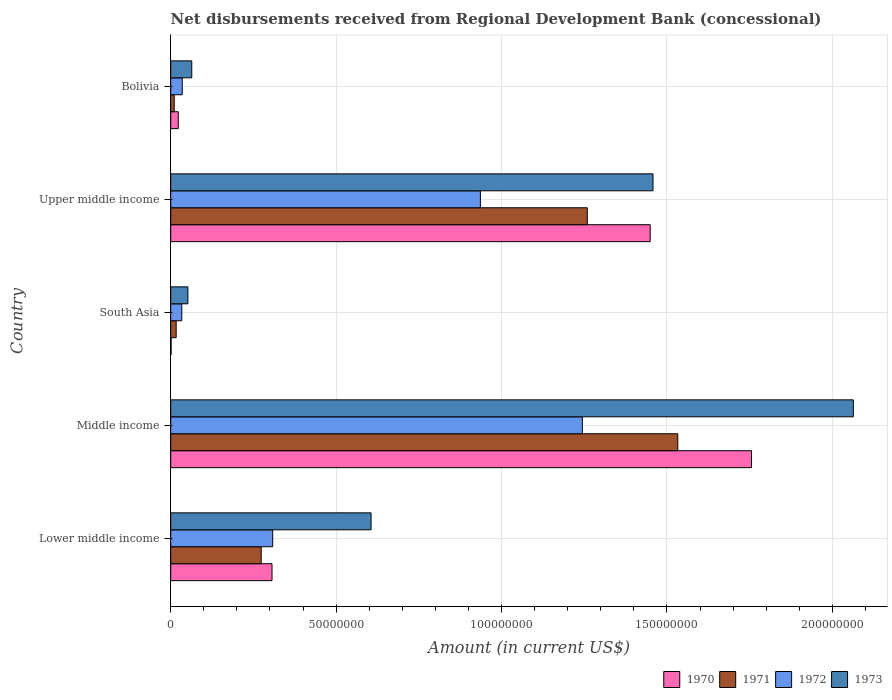How many different coloured bars are there?
Make the answer very short. 4. How many bars are there on the 2nd tick from the top?
Your answer should be very brief. 4. What is the label of the 4th group of bars from the top?
Keep it short and to the point. Middle income. In how many cases, is the number of bars for a given country not equal to the number of legend labels?
Provide a short and direct response. 0. What is the amount of disbursements received from Regional Development Bank in 1973 in Middle income?
Your answer should be very brief. 2.06e+08. Across all countries, what is the maximum amount of disbursements received from Regional Development Bank in 1970?
Your response must be concise. 1.76e+08. Across all countries, what is the minimum amount of disbursements received from Regional Development Bank in 1970?
Provide a short and direct response. 1.09e+05. In which country was the amount of disbursements received from Regional Development Bank in 1971 minimum?
Offer a terse response. Bolivia. What is the total amount of disbursements received from Regional Development Bank in 1971 in the graph?
Offer a very short reply. 3.09e+08. What is the difference between the amount of disbursements received from Regional Development Bank in 1971 in Bolivia and that in Middle income?
Give a very brief answer. -1.52e+08. What is the difference between the amount of disbursements received from Regional Development Bank in 1970 in Bolivia and the amount of disbursements received from Regional Development Bank in 1971 in Middle income?
Provide a short and direct response. -1.51e+08. What is the average amount of disbursements received from Regional Development Bank in 1970 per country?
Offer a very short reply. 7.07e+07. What is the difference between the amount of disbursements received from Regional Development Bank in 1970 and amount of disbursements received from Regional Development Bank in 1973 in Bolivia?
Make the answer very short. -4.09e+06. What is the ratio of the amount of disbursements received from Regional Development Bank in 1973 in Bolivia to that in Middle income?
Give a very brief answer. 0.03. Is the difference between the amount of disbursements received from Regional Development Bank in 1970 in Middle income and Upper middle income greater than the difference between the amount of disbursements received from Regional Development Bank in 1973 in Middle income and Upper middle income?
Offer a very short reply. No. What is the difference between the highest and the second highest amount of disbursements received from Regional Development Bank in 1972?
Your response must be concise. 3.08e+07. What is the difference between the highest and the lowest amount of disbursements received from Regional Development Bank in 1972?
Provide a short and direct response. 1.21e+08. Is the sum of the amount of disbursements received from Regional Development Bank in 1971 in Bolivia and Upper middle income greater than the maximum amount of disbursements received from Regional Development Bank in 1973 across all countries?
Keep it short and to the point. No. Is it the case that in every country, the sum of the amount of disbursements received from Regional Development Bank in 1973 and amount of disbursements received from Regional Development Bank in 1972 is greater than the sum of amount of disbursements received from Regional Development Bank in 1971 and amount of disbursements received from Regional Development Bank in 1970?
Ensure brevity in your answer.  No. What does the 2nd bar from the bottom in Upper middle income represents?
Your response must be concise. 1971. How many bars are there?
Keep it short and to the point. 20. Are all the bars in the graph horizontal?
Offer a terse response. Yes. Are the values on the major ticks of X-axis written in scientific E-notation?
Your response must be concise. No. Does the graph contain any zero values?
Make the answer very short. No. Where does the legend appear in the graph?
Provide a short and direct response. Bottom right. How are the legend labels stacked?
Your answer should be very brief. Horizontal. What is the title of the graph?
Make the answer very short. Net disbursements received from Regional Development Bank (concessional). What is the label or title of the X-axis?
Provide a short and direct response. Amount (in current US$). What is the label or title of the Y-axis?
Your answer should be compact. Country. What is the Amount (in current US$) in 1970 in Lower middle income?
Your response must be concise. 3.06e+07. What is the Amount (in current US$) in 1971 in Lower middle income?
Provide a succinct answer. 2.74e+07. What is the Amount (in current US$) in 1972 in Lower middle income?
Offer a terse response. 3.08e+07. What is the Amount (in current US$) of 1973 in Lower middle income?
Provide a succinct answer. 6.06e+07. What is the Amount (in current US$) in 1970 in Middle income?
Your response must be concise. 1.76e+08. What is the Amount (in current US$) in 1971 in Middle income?
Keep it short and to the point. 1.53e+08. What is the Amount (in current US$) of 1972 in Middle income?
Ensure brevity in your answer.  1.24e+08. What is the Amount (in current US$) in 1973 in Middle income?
Offer a very short reply. 2.06e+08. What is the Amount (in current US$) of 1970 in South Asia?
Your answer should be very brief. 1.09e+05. What is the Amount (in current US$) in 1971 in South Asia?
Your answer should be very brief. 1.65e+06. What is the Amount (in current US$) of 1972 in South Asia?
Keep it short and to the point. 3.35e+06. What is the Amount (in current US$) of 1973 in South Asia?
Your answer should be very brief. 5.18e+06. What is the Amount (in current US$) in 1970 in Upper middle income?
Provide a succinct answer. 1.45e+08. What is the Amount (in current US$) in 1971 in Upper middle income?
Provide a succinct answer. 1.26e+08. What is the Amount (in current US$) in 1972 in Upper middle income?
Provide a succinct answer. 9.36e+07. What is the Amount (in current US$) of 1973 in Upper middle income?
Give a very brief answer. 1.46e+08. What is the Amount (in current US$) of 1970 in Bolivia?
Your response must be concise. 2.27e+06. What is the Amount (in current US$) of 1971 in Bolivia?
Offer a very short reply. 1.06e+06. What is the Amount (in current US$) of 1972 in Bolivia?
Your answer should be compact. 3.48e+06. What is the Amount (in current US$) of 1973 in Bolivia?
Your answer should be very brief. 6.36e+06. Across all countries, what is the maximum Amount (in current US$) of 1970?
Offer a terse response. 1.76e+08. Across all countries, what is the maximum Amount (in current US$) in 1971?
Ensure brevity in your answer.  1.53e+08. Across all countries, what is the maximum Amount (in current US$) in 1972?
Make the answer very short. 1.24e+08. Across all countries, what is the maximum Amount (in current US$) of 1973?
Provide a short and direct response. 2.06e+08. Across all countries, what is the minimum Amount (in current US$) in 1970?
Your response must be concise. 1.09e+05. Across all countries, what is the minimum Amount (in current US$) of 1971?
Make the answer very short. 1.06e+06. Across all countries, what is the minimum Amount (in current US$) of 1972?
Your answer should be compact. 3.35e+06. Across all countries, what is the minimum Amount (in current US$) of 1973?
Your answer should be compact. 5.18e+06. What is the total Amount (in current US$) in 1970 in the graph?
Keep it short and to the point. 3.53e+08. What is the total Amount (in current US$) in 1971 in the graph?
Your answer should be compact. 3.09e+08. What is the total Amount (in current US$) in 1972 in the graph?
Keep it short and to the point. 2.56e+08. What is the total Amount (in current US$) of 1973 in the graph?
Give a very brief answer. 4.24e+08. What is the difference between the Amount (in current US$) of 1970 in Lower middle income and that in Middle income?
Your answer should be compact. -1.45e+08. What is the difference between the Amount (in current US$) in 1971 in Lower middle income and that in Middle income?
Provide a short and direct response. -1.26e+08. What is the difference between the Amount (in current US$) of 1972 in Lower middle income and that in Middle income?
Your answer should be compact. -9.36e+07. What is the difference between the Amount (in current US$) in 1973 in Lower middle income and that in Middle income?
Give a very brief answer. -1.46e+08. What is the difference between the Amount (in current US$) in 1970 in Lower middle income and that in South Asia?
Provide a short and direct response. 3.05e+07. What is the difference between the Amount (in current US$) of 1971 in Lower middle income and that in South Asia?
Make the answer very short. 2.57e+07. What is the difference between the Amount (in current US$) of 1972 in Lower middle income and that in South Asia?
Give a very brief answer. 2.75e+07. What is the difference between the Amount (in current US$) in 1973 in Lower middle income and that in South Asia?
Keep it short and to the point. 5.54e+07. What is the difference between the Amount (in current US$) in 1970 in Lower middle income and that in Upper middle income?
Your response must be concise. -1.14e+08. What is the difference between the Amount (in current US$) in 1971 in Lower middle income and that in Upper middle income?
Provide a short and direct response. -9.86e+07. What is the difference between the Amount (in current US$) of 1972 in Lower middle income and that in Upper middle income?
Make the answer very short. -6.28e+07. What is the difference between the Amount (in current US$) of 1973 in Lower middle income and that in Upper middle income?
Provide a short and direct response. -8.52e+07. What is the difference between the Amount (in current US$) in 1970 in Lower middle income and that in Bolivia?
Give a very brief answer. 2.84e+07. What is the difference between the Amount (in current US$) of 1971 in Lower middle income and that in Bolivia?
Ensure brevity in your answer.  2.63e+07. What is the difference between the Amount (in current US$) in 1972 in Lower middle income and that in Bolivia?
Provide a succinct answer. 2.73e+07. What is the difference between the Amount (in current US$) in 1973 in Lower middle income and that in Bolivia?
Your answer should be compact. 5.42e+07. What is the difference between the Amount (in current US$) of 1970 in Middle income and that in South Asia?
Provide a short and direct response. 1.75e+08. What is the difference between the Amount (in current US$) of 1971 in Middle income and that in South Asia?
Give a very brief answer. 1.52e+08. What is the difference between the Amount (in current US$) of 1972 in Middle income and that in South Asia?
Offer a terse response. 1.21e+08. What is the difference between the Amount (in current US$) in 1973 in Middle income and that in South Asia?
Keep it short and to the point. 2.01e+08. What is the difference between the Amount (in current US$) in 1970 in Middle income and that in Upper middle income?
Give a very brief answer. 3.06e+07. What is the difference between the Amount (in current US$) in 1971 in Middle income and that in Upper middle income?
Give a very brief answer. 2.74e+07. What is the difference between the Amount (in current US$) in 1972 in Middle income and that in Upper middle income?
Offer a terse response. 3.08e+07. What is the difference between the Amount (in current US$) of 1973 in Middle income and that in Upper middle income?
Your answer should be compact. 6.06e+07. What is the difference between the Amount (in current US$) of 1970 in Middle income and that in Bolivia?
Your answer should be compact. 1.73e+08. What is the difference between the Amount (in current US$) in 1971 in Middle income and that in Bolivia?
Offer a terse response. 1.52e+08. What is the difference between the Amount (in current US$) in 1972 in Middle income and that in Bolivia?
Provide a succinct answer. 1.21e+08. What is the difference between the Amount (in current US$) in 1973 in Middle income and that in Bolivia?
Offer a terse response. 2.00e+08. What is the difference between the Amount (in current US$) of 1970 in South Asia and that in Upper middle income?
Offer a terse response. -1.45e+08. What is the difference between the Amount (in current US$) in 1971 in South Asia and that in Upper middle income?
Offer a terse response. -1.24e+08. What is the difference between the Amount (in current US$) of 1972 in South Asia and that in Upper middle income?
Your answer should be compact. -9.03e+07. What is the difference between the Amount (in current US$) of 1973 in South Asia and that in Upper middle income?
Offer a terse response. -1.41e+08. What is the difference between the Amount (in current US$) of 1970 in South Asia and that in Bolivia?
Your answer should be compact. -2.16e+06. What is the difference between the Amount (in current US$) in 1971 in South Asia and that in Bolivia?
Give a very brief answer. 5.92e+05. What is the difference between the Amount (in current US$) of 1972 in South Asia and that in Bolivia?
Give a very brief answer. -1.30e+05. What is the difference between the Amount (in current US$) of 1973 in South Asia and that in Bolivia?
Your answer should be very brief. -1.18e+06. What is the difference between the Amount (in current US$) in 1970 in Upper middle income and that in Bolivia?
Provide a short and direct response. 1.43e+08. What is the difference between the Amount (in current US$) in 1971 in Upper middle income and that in Bolivia?
Make the answer very short. 1.25e+08. What is the difference between the Amount (in current US$) in 1972 in Upper middle income and that in Bolivia?
Offer a very short reply. 9.01e+07. What is the difference between the Amount (in current US$) of 1973 in Upper middle income and that in Bolivia?
Give a very brief answer. 1.39e+08. What is the difference between the Amount (in current US$) in 1970 in Lower middle income and the Amount (in current US$) in 1971 in Middle income?
Provide a short and direct response. -1.23e+08. What is the difference between the Amount (in current US$) of 1970 in Lower middle income and the Amount (in current US$) of 1972 in Middle income?
Keep it short and to the point. -9.38e+07. What is the difference between the Amount (in current US$) in 1970 in Lower middle income and the Amount (in current US$) in 1973 in Middle income?
Offer a very short reply. -1.76e+08. What is the difference between the Amount (in current US$) of 1971 in Lower middle income and the Amount (in current US$) of 1972 in Middle income?
Ensure brevity in your answer.  -9.71e+07. What is the difference between the Amount (in current US$) of 1971 in Lower middle income and the Amount (in current US$) of 1973 in Middle income?
Offer a terse response. -1.79e+08. What is the difference between the Amount (in current US$) of 1972 in Lower middle income and the Amount (in current US$) of 1973 in Middle income?
Offer a terse response. -1.76e+08. What is the difference between the Amount (in current US$) in 1970 in Lower middle income and the Amount (in current US$) in 1971 in South Asia?
Provide a succinct answer. 2.90e+07. What is the difference between the Amount (in current US$) of 1970 in Lower middle income and the Amount (in current US$) of 1972 in South Asia?
Make the answer very short. 2.73e+07. What is the difference between the Amount (in current US$) of 1970 in Lower middle income and the Amount (in current US$) of 1973 in South Asia?
Your response must be concise. 2.54e+07. What is the difference between the Amount (in current US$) of 1971 in Lower middle income and the Amount (in current US$) of 1972 in South Asia?
Ensure brevity in your answer.  2.40e+07. What is the difference between the Amount (in current US$) in 1971 in Lower middle income and the Amount (in current US$) in 1973 in South Asia?
Keep it short and to the point. 2.22e+07. What is the difference between the Amount (in current US$) in 1972 in Lower middle income and the Amount (in current US$) in 1973 in South Asia?
Keep it short and to the point. 2.56e+07. What is the difference between the Amount (in current US$) in 1970 in Lower middle income and the Amount (in current US$) in 1971 in Upper middle income?
Keep it short and to the point. -9.53e+07. What is the difference between the Amount (in current US$) of 1970 in Lower middle income and the Amount (in current US$) of 1972 in Upper middle income?
Ensure brevity in your answer.  -6.30e+07. What is the difference between the Amount (in current US$) of 1970 in Lower middle income and the Amount (in current US$) of 1973 in Upper middle income?
Provide a short and direct response. -1.15e+08. What is the difference between the Amount (in current US$) of 1971 in Lower middle income and the Amount (in current US$) of 1972 in Upper middle income?
Offer a terse response. -6.63e+07. What is the difference between the Amount (in current US$) in 1971 in Lower middle income and the Amount (in current US$) in 1973 in Upper middle income?
Make the answer very short. -1.18e+08. What is the difference between the Amount (in current US$) in 1972 in Lower middle income and the Amount (in current US$) in 1973 in Upper middle income?
Provide a short and direct response. -1.15e+08. What is the difference between the Amount (in current US$) in 1970 in Lower middle income and the Amount (in current US$) in 1971 in Bolivia?
Offer a very short reply. 2.96e+07. What is the difference between the Amount (in current US$) of 1970 in Lower middle income and the Amount (in current US$) of 1972 in Bolivia?
Provide a short and direct response. 2.71e+07. What is the difference between the Amount (in current US$) of 1970 in Lower middle income and the Amount (in current US$) of 1973 in Bolivia?
Make the answer very short. 2.43e+07. What is the difference between the Amount (in current US$) of 1971 in Lower middle income and the Amount (in current US$) of 1972 in Bolivia?
Ensure brevity in your answer.  2.39e+07. What is the difference between the Amount (in current US$) in 1971 in Lower middle income and the Amount (in current US$) in 1973 in Bolivia?
Your answer should be compact. 2.10e+07. What is the difference between the Amount (in current US$) in 1972 in Lower middle income and the Amount (in current US$) in 1973 in Bolivia?
Offer a very short reply. 2.45e+07. What is the difference between the Amount (in current US$) in 1970 in Middle income and the Amount (in current US$) in 1971 in South Asia?
Provide a short and direct response. 1.74e+08. What is the difference between the Amount (in current US$) in 1970 in Middle income and the Amount (in current US$) in 1972 in South Asia?
Provide a short and direct response. 1.72e+08. What is the difference between the Amount (in current US$) in 1970 in Middle income and the Amount (in current US$) in 1973 in South Asia?
Keep it short and to the point. 1.70e+08. What is the difference between the Amount (in current US$) of 1971 in Middle income and the Amount (in current US$) of 1972 in South Asia?
Offer a very short reply. 1.50e+08. What is the difference between the Amount (in current US$) of 1971 in Middle income and the Amount (in current US$) of 1973 in South Asia?
Keep it short and to the point. 1.48e+08. What is the difference between the Amount (in current US$) of 1972 in Middle income and the Amount (in current US$) of 1973 in South Asia?
Provide a succinct answer. 1.19e+08. What is the difference between the Amount (in current US$) in 1970 in Middle income and the Amount (in current US$) in 1971 in Upper middle income?
Keep it short and to the point. 4.96e+07. What is the difference between the Amount (in current US$) in 1970 in Middle income and the Amount (in current US$) in 1972 in Upper middle income?
Your response must be concise. 8.19e+07. What is the difference between the Amount (in current US$) in 1970 in Middle income and the Amount (in current US$) in 1973 in Upper middle income?
Offer a terse response. 2.98e+07. What is the difference between the Amount (in current US$) in 1971 in Middle income and the Amount (in current US$) in 1972 in Upper middle income?
Offer a very short reply. 5.97e+07. What is the difference between the Amount (in current US$) of 1971 in Middle income and the Amount (in current US$) of 1973 in Upper middle income?
Keep it short and to the point. 7.49e+06. What is the difference between the Amount (in current US$) of 1972 in Middle income and the Amount (in current US$) of 1973 in Upper middle income?
Offer a terse response. -2.14e+07. What is the difference between the Amount (in current US$) of 1970 in Middle income and the Amount (in current US$) of 1971 in Bolivia?
Offer a terse response. 1.74e+08. What is the difference between the Amount (in current US$) in 1970 in Middle income and the Amount (in current US$) in 1972 in Bolivia?
Offer a terse response. 1.72e+08. What is the difference between the Amount (in current US$) of 1970 in Middle income and the Amount (in current US$) of 1973 in Bolivia?
Your answer should be very brief. 1.69e+08. What is the difference between the Amount (in current US$) of 1971 in Middle income and the Amount (in current US$) of 1972 in Bolivia?
Keep it short and to the point. 1.50e+08. What is the difference between the Amount (in current US$) of 1971 in Middle income and the Amount (in current US$) of 1973 in Bolivia?
Your answer should be compact. 1.47e+08. What is the difference between the Amount (in current US$) of 1972 in Middle income and the Amount (in current US$) of 1973 in Bolivia?
Your answer should be very brief. 1.18e+08. What is the difference between the Amount (in current US$) of 1970 in South Asia and the Amount (in current US$) of 1971 in Upper middle income?
Make the answer very short. -1.26e+08. What is the difference between the Amount (in current US$) of 1970 in South Asia and the Amount (in current US$) of 1972 in Upper middle income?
Offer a very short reply. -9.35e+07. What is the difference between the Amount (in current US$) of 1970 in South Asia and the Amount (in current US$) of 1973 in Upper middle income?
Keep it short and to the point. -1.46e+08. What is the difference between the Amount (in current US$) of 1971 in South Asia and the Amount (in current US$) of 1972 in Upper middle income?
Provide a short and direct response. -9.20e+07. What is the difference between the Amount (in current US$) of 1971 in South Asia and the Amount (in current US$) of 1973 in Upper middle income?
Make the answer very short. -1.44e+08. What is the difference between the Amount (in current US$) in 1972 in South Asia and the Amount (in current US$) in 1973 in Upper middle income?
Offer a terse response. -1.42e+08. What is the difference between the Amount (in current US$) in 1970 in South Asia and the Amount (in current US$) in 1971 in Bolivia?
Ensure brevity in your answer.  -9.49e+05. What is the difference between the Amount (in current US$) of 1970 in South Asia and the Amount (in current US$) of 1972 in Bolivia?
Your answer should be compact. -3.37e+06. What is the difference between the Amount (in current US$) in 1970 in South Asia and the Amount (in current US$) in 1973 in Bolivia?
Your answer should be very brief. -6.25e+06. What is the difference between the Amount (in current US$) in 1971 in South Asia and the Amount (in current US$) in 1972 in Bolivia?
Your answer should be very brief. -1.83e+06. What is the difference between the Amount (in current US$) of 1971 in South Asia and the Amount (in current US$) of 1973 in Bolivia?
Keep it short and to the point. -4.71e+06. What is the difference between the Amount (in current US$) in 1972 in South Asia and the Amount (in current US$) in 1973 in Bolivia?
Keep it short and to the point. -3.01e+06. What is the difference between the Amount (in current US$) of 1970 in Upper middle income and the Amount (in current US$) of 1971 in Bolivia?
Ensure brevity in your answer.  1.44e+08. What is the difference between the Amount (in current US$) of 1970 in Upper middle income and the Amount (in current US$) of 1972 in Bolivia?
Your answer should be very brief. 1.41e+08. What is the difference between the Amount (in current US$) in 1970 in Upper middle income and the Amount (in current US$) in 1973 in Bolivia?
Offer a very short reply. 1.39e+08. What is the difference between the Amount (in current US$) of 1971 in Upper middle income and the Amount (in current US$) of 1972 in Bolivia?
Ensure brevity in your answer.  1.22e+08. What is the difference between the Amount (in current US$) of 1971 in Upper middle income and the Amount (in current US$) of 1973 in Bolivia?
Your response must be concise. 1.20e+08. What is the difference between the Amount (in current US$) in 1972 in Upper middle income and the Amount (in current US$) in 1973 in Bolivia?
Provide a succinct answer. 8.72e+07. What is the average Amount (in current US$) in 1970 per country?
Ensure brevity in your answer.  7.07e+07. What is the average Amount (in current US$) in 1971 per country?
Offer a terse response. 6.19e+07. What is the average Amount (in current US$) of 1972 per country?
Keep it short and to the point. 5.11e+07. What is the average Amount (in current US$) in 1973 per country?
Your answer should be compact. 8.48e+07. What is the difference between the Amount (in current US$) in 1970 and Amount (in current US$) in 1971 in Lower middle income?
Your answer should be very brief. 3.27e+06. What is the difference between the Amount (in current US$) of 1970 and Amount (in current US$) of 1972 in Lower middle income?
Ensure brevity in your answer.  -2.02e+05. What is the difference between the Amount (in current US$) of 1970 and Amount (in current US$) of 1973 in Lower middle income?
Make the answer very short. -2.99e+07. What is the difference between the Amount (in current US$) of 1971 and Amount (in current US$) of 1972 in Lower middle income?
Provide a short and direct response. -3.47e+06. What is the difference between the Amount (in current US$) in 1971 and Amount (in current US$) in 1973 in Lower middle income?
Offer a very short reply. -3.32e+07. What is the difference between the Amount (in current US$) in 1972 and Amount (in current US$) in 1973 in Lower middle income?
Ensure brevity in your answer.  -2.97e+07. What is the difference between the Amount (in current US$) in 1970 and Amount (in current US$) in 1971 in Middle income?
Your answer should be very brief. 2.23e+07. What is the difference between the Amount (in current US$) in 1970 and Amount (in current US$) in 1972 in Middle income?
Offer a very short reply. 5.11e+07. What is the difference between the Amount (in current US$) in 1970 and Amount (in current US$) in 1973 in Middle income?
Offer a very short reply. -3.08e+07. What is the difference between the Amount (in current US$) of 1971 and Amount (in current US$) of 1972 in Middle income?
Make the answer very short. 2.88e+07. What is the difference between the Amount (in current US$) in 1971 and Amount (in current US$) in 1973 in Middle income?
Offer a very short reply. -5.31e+07. What is the difference between the Amount (in current US$) in 1972 and Amount (in current US$) in 1973 in Middle income?
Provide a succinct answer. -8.19e+07. What is the difference between the Amount (in current US$) of 1970 and Amount (in current US$) of 1971 in South Asia?
Keep it short and to the point. -1.54e+06. What is the difference between the Amount (in current US$) of 1970 and Amount (in current US$) of 1972 in South Asia?
Offer a very short reply. -3.24e+06. What is the difference between the Amount (in current US$) in 1970 and Amount (in current US$) in 1973 in South Asia?
Give a very brief answer. -5.08e+06. What is the difference between the Amount (in current US$) in 1971 and Amount (in current US$) in 1972 in South Asia?
Make the answer very short. -1.70e+06. What is the difference between the Amount (in current US$) of 1971 and Amount (in current US$) of 1973 in South Asia?
Give a very brief answer. -3.53e+06. What is the difference between the Amount (in current US$) of 1972 and Amount (in current US$) of 1973 in South Asia?
Your response must be concise. -1.83e+06. What is the difference between the Amount (in current US$) of 1970 and Amount (in current US$) of 1971 in Upper middle income?
Give a very brief answer. 1.90e+07. What is the difference between the Amount (in current US$) in 1970 and Amount (in current US$) in 1972 in Upper middle income?
Your answer should be compact. 5.13e+07. What is the difference between the Amount (in current US$) of 1970 and Amount (in current US$) of 1973 in Upper middle income?
Provide a succinct answer. -8.58e+05. What is the difference between the Amount (in current US$) of 1971 and Amount (in current US$) of 1972 in Upper middle income?
Your answer should be very brief. 3.23e+07. What is the difference between the Amount (in current US$) in 1971 and Amount (in current US$) in 1973 in Upper middle income?
Your answer should be very brief. -1.99e+07. What is the difference between the Amount (in current US$) in 1972 and Amount (in current US$) in 1973 in Upper middle income?
Your answer should be very brief. -5.22e+07. What is the difference between the Amount (in current US$) in 1970 and Amount (in current US$) in 1971 in Bolivia?
Offer a very short reply. 1.21e+06. What is the difference between the Amount (in current US$) in 1970 and Amount (in current US$) in 1972 in Bolivia?
Give a very brief answer. -1.21e+06. What is the difference between the Amount (in current US$) in 1970 and Amount (in current US$) in 1973 in Bolivia?
Your response must be concise. -4.09e+06. What is the difference between the Amount (in current US$) in 1971 and Amount (in current US$) in 1972 in Bolivia?
Provide a short and direct response. -2.42e+06. What is the difference between the Amount (in current US$) in 1971 and Amount (in current US$) in 1973 in Bolivia?
Give a very brief answer. -5.30e+06. What is the difference between the Amount (in current US$) in 1972 and Amount (in current US$) in 1973 in Bolivia?
Provide a short and direct response. -2.88e+06. What is the ratio of the Amount (in current US$) of 1970 in Lower middle income to that in Middle income?
Provide a short and direct response. 0.17. What is the ratio of the Amount (in current US$) of 1971 in Lower middle income to that in Middle income?
Give a very brief answer. 0.18. What is the ratio of the Amount (in current US$) of 1972 in Lower middle income to that in Middle income?
Ensure brevity in your answer.  0.25. What is the ratio of the Amount (in current US$) in 1973 in Lower middle income to that in Middle income?
Ensure brevity in your answer.  0.29. What is the ratio of the Amount (in current US$) in 1970 in Lower middle income to that in South Asia?
Offer a very short reply. 280.94. What is the ratio of the Amount (in current US$) in 1971 in Lower middle income to that in South Asia?
Ensure brevity in your answer.  16.58. What is the ratio of the Amount (in current US$) of 1972 in Lower middle income to that in South Asia?
Make the answer very short. 9.2. What is the ratio of the Amount (in current US$) in 1973 in Lower middle income to that in South Asia?
Your answer should be compact. 11.68. What is the ratio of the Amount (in current US$) of 1970 in Lower middle income to that in Upper middle income?
Provide a succinct answer. 0.21. What is the ratio of the Amount (in current US$) in 1971 in Lower middle income to that in Upper middle income?
Ensure brevity in your answer.  0.22. What is the ratio of the Amount (in current US$) of 1972 in Lower middle income to that in Upper middle income?
Your response must be concise. 0.33. What is the ratio of the Amount (in current US$) in 1973 in Lower middle income to that in Upper middle income?
Provide a succinct answer. 0.42. What is the ratio of the Amount (in current US$) of 1970 in Lower middle income to that in Bolivia?
Keep it short and to the point. 13.49. What is the ratio of the Amount (in current US$) of 1971 in Lower middle income to that in Bolivia?
Provide a short and direct response. 25.85. What is the ratio of the Amount (in current US$) of 1972 in Lower middle income to that in Bolivia?
Keep it short and to the point. 8.86. What is the ratio of the Amount (in current US$) in 1973 in Lower middle income to that in Bolivia?
Provide a succinct answer. 9.52. What is the ratio of the Amount (in current US$) in 1970 in Middle income to that in South Asia?
Offer a very short reply. 1610.58. What is the ratio of the Amount (in current US$) in 1971 in Middle income to that in South Asia?
Provide a succinct answer. 92.89. What is the ratio of the Amount (in current US$) in 1972 in Middle income to that in South Asia?
Offer a very short reply. 37.14. What is the ratio of the Amount (in current US$) in 1973 in Middle income to that in South Asia?
Your answer should be very brief. 39.8. What is the ratio of the Amount (in current US$) in 1970 in Middle income to that in Upper middle income?
Keep it short and to the point. 1.21. What is the ratio of the Amount (in current US$) in 1971 in Middle income to that in Upper middle income?
Your response must be concise. 1.22. What is the ratio of the Amount (in current US$) of 1972 in Middle income to that in Upper middle income?
Ensure brevity in your answer.  1.33. What is the ratio of the Amount (in current US$) in 1973 in Middle income to that in Upper middle income?
Give a very brief answer. 1.42. What is the ratio of the Amount (in current US$) of 1970 in Middle income to that in Bolivia?
Ensure brevity in your answer.  77.34. What is the ratio of the Amount (in current US$) of 1971 in Middle income to that in Bolivia?
Your answer should be very brief. 144.87. What is the ratio of the Amount (in current US$) of 1972 in Middle income to that in Bolivia?
Your response must be concise. 35.76. What is the ratio of the Amount (in current US$) in 1973 in Middle income to that in Bolivia?
Give a very brief answer. 32.44. What is the ratio of the Amount (in current US$) of 1970 in South Asia to that in Upper middle income?
Your response must be concise. 0. What is the ratio of the Amount (in current US$) in 1971 in South Asia to that in Upper middle income?
Keep it short and to the point. 0.01. What is the ratio of the Amount (in current US$) of 1972 in South Asia to that in Upper middle income?
Give a very brief answer. 0.04. What is the ratio of the Amount (in current US$) in 1973 in South Asia to that in Upper middle income?
Provide a succinct answer. 0.04. What is the ratio of the Amount (in current US$) in 1970 in South Asia to that in Bolivia?
Give a very brief answer. 0.05. What is the ratio of the Amount (in current US$) in 1971 in South Asia to that in Bolivia?
Ensure brevity in your answer.  1.56. What is the ratio of the Amount (in current US$) in 1972 in South Asia to that in Bolivia?
Your answer should be very brief. 0.96. What is the ratio of the Amount (in current US$) in 1973 in South Asia to that in Bolivia?
Offer a very short reply. 0.82. What is the ratio of the Amount (in current US$) of 1970 in Upper middle income to that in Bolivia?
Provide a succinct answer. 63.85. What is the ratio of the Amount (in current US$) of 1971 in Upper middle income to that in Bolivia?
Your answer should be very brief. 119.02. What is the ratio of the Amount (in current US$) in 1972 in Upper middle income to that in Bolivia?
Your answer should be compact. 26.9. What is the ratio of the Amount (in current US$) of 1973 in Upper middle income to that in Bolivia?
Keep it short and to the point. 22.92. What is the difference between the highest and the second highest Amount (in current US$) of 1970?
Your response must be concise. 3.06e+07. What is the difference between the highest and the second highest Amount (in current US$) of 1971?
Offer a very short reply. 2.74e+07. What is the difference between the highest and the second highest Amount (in current US$) of 1972?
Give a very brief answer. 3.08e+07. What is the difference between the highest and the second highest Amount (in current US$) in 1973?
Offer a very short reply. 6.06e+07. What is the difference between the highest and the lowest Amount (in current US$) of 1970?
Offer a very short reply. 1.75e+08. What is the difference between the highest and the lowest Amount (in current US$) of 1971?
Provide a short and direct response. 1.52e+08. What is the difference between the highest and the lowest Amount (in current US$) in 1972?
Give a very brief answer. 1.21e+08. What is the difference between the highest and the lowest Amount (in current US$) of 1973?
Your answer should be very brief. 2.01e+08. 